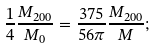Convert formula to latex. <formula><loc_0><loc_0><loc_500><loc_500>\frac { 1 } { 4 } \frac { M _ { 2 0 0 } } { M _ { 0 } } = \frac { 3 7 5 } { 5 6 \pi } \frac { M _ { 2 0 0 } } M ;</formula> 